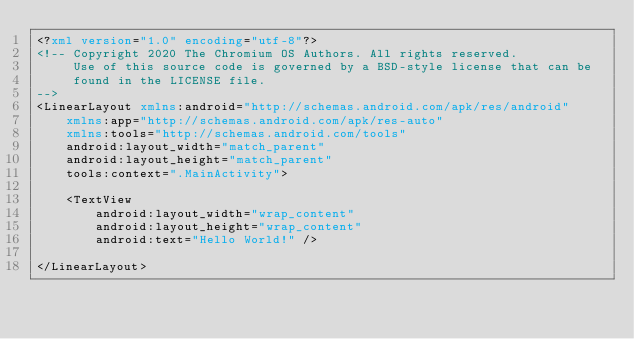<code> <loc_0><loc_0><loc_500><loc_500><_XML_><?xml version="1.0" encoding="utf-8"?>
<!-- Copyright 2020 The Chromium OS Authors. All rights reserved.
     Use of this source code is governed by a BSD-style license that can be
     found in the LICENSE file.
-->
<LinearLayout xmlns:android="http://schemas.android.com/apk/res/android"
    xmlns:app="http://schemas.android.com/apk/res-auto"
    xmlns:tools="http://schemas.android.com/tools"
    android:layout_width="match_parent"
    android:layout_height="match_parent"
    tools:context=".MainActivity">

    <TextView
        android:layout_width="wrap_content"
        android:layout_height="wrap_content"
        android:text="Hello World!" />

</LinearLayout>
</code> 